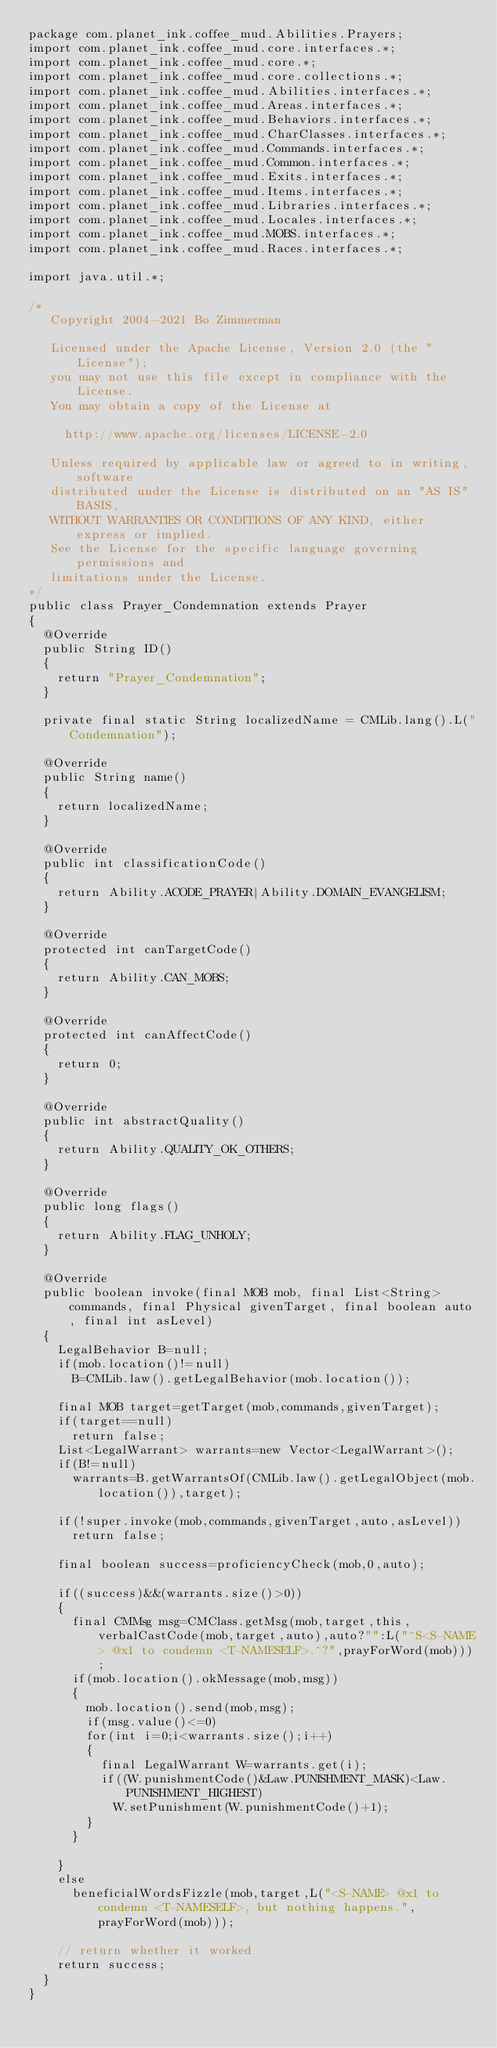Convert code to text. <code><loc_0><loc_0><loc_500><loc_500><_Java_>package com.planet_ink.coffee_mud.Abilities.Prayers;
import com.planet_ink.coffee_mud.core.interfaces.*;
import com.planet_ink.coffee_mud.core.*;
import com.planet_ink.coffee_mud.core.collections.*;
import com.planet_ink.coffee_mud.Abilities.interfaces.*;
import com.planet_ink.coffee_mud.Areas.interfaces.*;
import com.planet_ink.coffee_mud.Behaviors.interfaces.*;
import com.planet_ink.coffee_mud.CharClasses.interfaces.*;
import com.planet_ink.coffee_mud.Commands.interfaces.*;
import com.planet_ink.coffee_mud.Common.interfaces.*;
import com.planet_ink.coffee_mud.Exits.interfaces.*;
import com.planet_ink.coffee_mud.Items.interfaces.*;
import com.planet_ink.coffee_mud.Libraries.interfaces.*;
import com.planet_ink.coffee_mud.Locales.interfaces.*;
import com.planet_ink.coffee_mud.MOBS.interfaces.*;
import com.planet_ink.coffee_mud.Races.interfaces.*;

import java.util.*;

/*
   Copyright 2004-2021 Bo Zimmerman

   Licensed under the Apache License, Version 2.0 (the "License");
   you may not use this file except in compliance with the License.
   You may obtain a copy of the License at

	   http://www.apache.org/licenses/LICENSE-2.0

   Unless required by applicable law or agreed to in writing, software
   distributed under the License is distributed on an "AS IS" BASIS,
   WITHOUT WARRANTIES OR CONDITIONS OF ANY KIND, either express or implied.
   See the License for the specific language governing permissions and
   limitations under the License.
*/
public class Prayer_Condemnation extends Prayer
{
	@Override
	public String ID()
	{
		return "Prayer_Condemnation";
	}

	private final static String localizedName = CMLib.lang().L("Condemnation");

	@Override
	public String name()
	{
		return localizedName;
	}

	@Override
	public int classificationCode()
	{
		return Ability.ACODE_PRAYER|Ability.DOMAIN_EVANGELISM;
	}

	@Override
	protected int canTargetCode()
	{
		return Ability.CAN_MOBS;
	}

	@Override
	protected int canAffectCode()
	{
		return 0;
	}

	@Override
	public int abstractQuality()
	{
		return Ability.QUALITY_OK_OTHERS;
	}

	@Override
	public long flags()
	{
		return Ability.FLAG_UNHOLY;
	}

	@Override
	public boolean invoke(final MOB mob, final List<String> commands, final Physical givenTarget, final boolean auto, final int asLevel)
	{
		LegalBehavior B=null;
		if(mob.location()!=null)
			B=CMLib.law().getLegalBehavior(mob.location());

		final MOB target=getTarget(mob,commands,givenTarget);
		if(target==null)
			return false;
		List<LegalWarrant> warrants=new Vector<LegalWarrant>();
		if(B!=null)
			warrants=B.getWarrantsOf(CMLib.law().getLegalObject(mob.location()),target);

		if(!super.invoke(mob,commands,givenTarget,auto,asLevel))
			return false;

		final boolean success=proficiencyCheck(mob,0,auto);

		if((success)&&(warrants.size()>0))
		{
			final CMMsg msg=CMClass.getMsg(mob,target,this,verbalCastCode(mob,target,auto),auto?"":L("^S<S-NAME> @x1 to condemn <T-NAMESELF>.^?",prayForWord(mob)));
			if(mob.location().okMessage(mob,msg))
			{
				mob.location().send(mob,msg);
				if(msg.value()<=0)
				for(int i=0;i<warrants.size();i++)
				{
					final LegalWarrant W=warrants.get(i);
					if((W.punishmentCode()&Law.PUNISHMENT_MASK)<Law.PUNISHMENT_HIGHEST)
						W.setPunishment(W.punishmentCode()+1);
				}
			}

		}
		else
			beneficialWordsFizzle(mob,target,L("<S-NAME> @x1 to condemn <T-NAMESELF>, but nothing happens.",prayForWord(mob)));

		// return whether it worked
		return success;
	}
}
</code> 